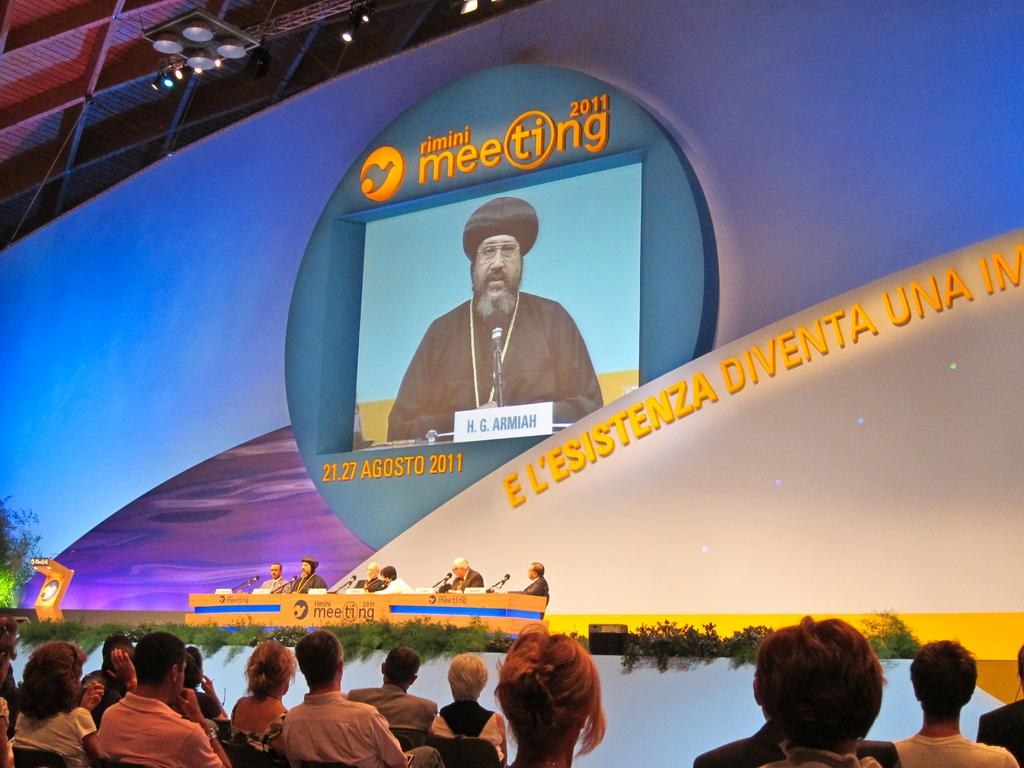<image>
Describe the image concisely. A crowd watching a large screen at the Rimini Meeting 2011. 